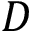Convert formula to latex. <formula><loc_0><loc_0><loc_500><loc_500>D</formula> 